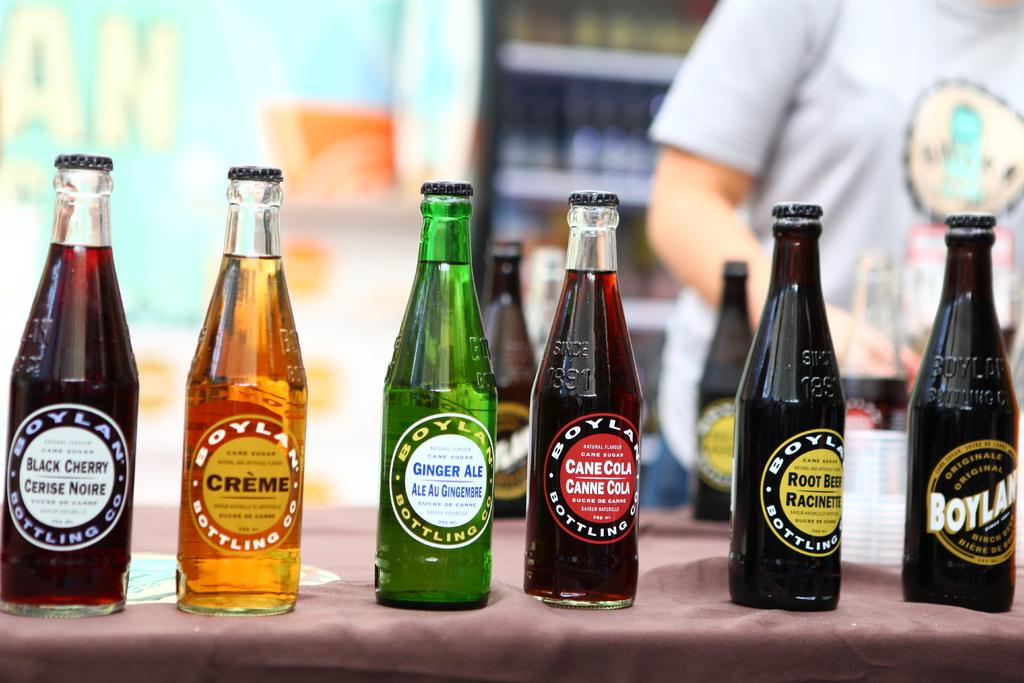What objects are on the table in the image? There are glass bottles on the table. Can you describe the background of the image? There is a person standing in the background and a rack in the background. What type of school is depicted in the image? There is no school present in the image; it only features glass bottles on a table and a person standing in the background with a rack. 